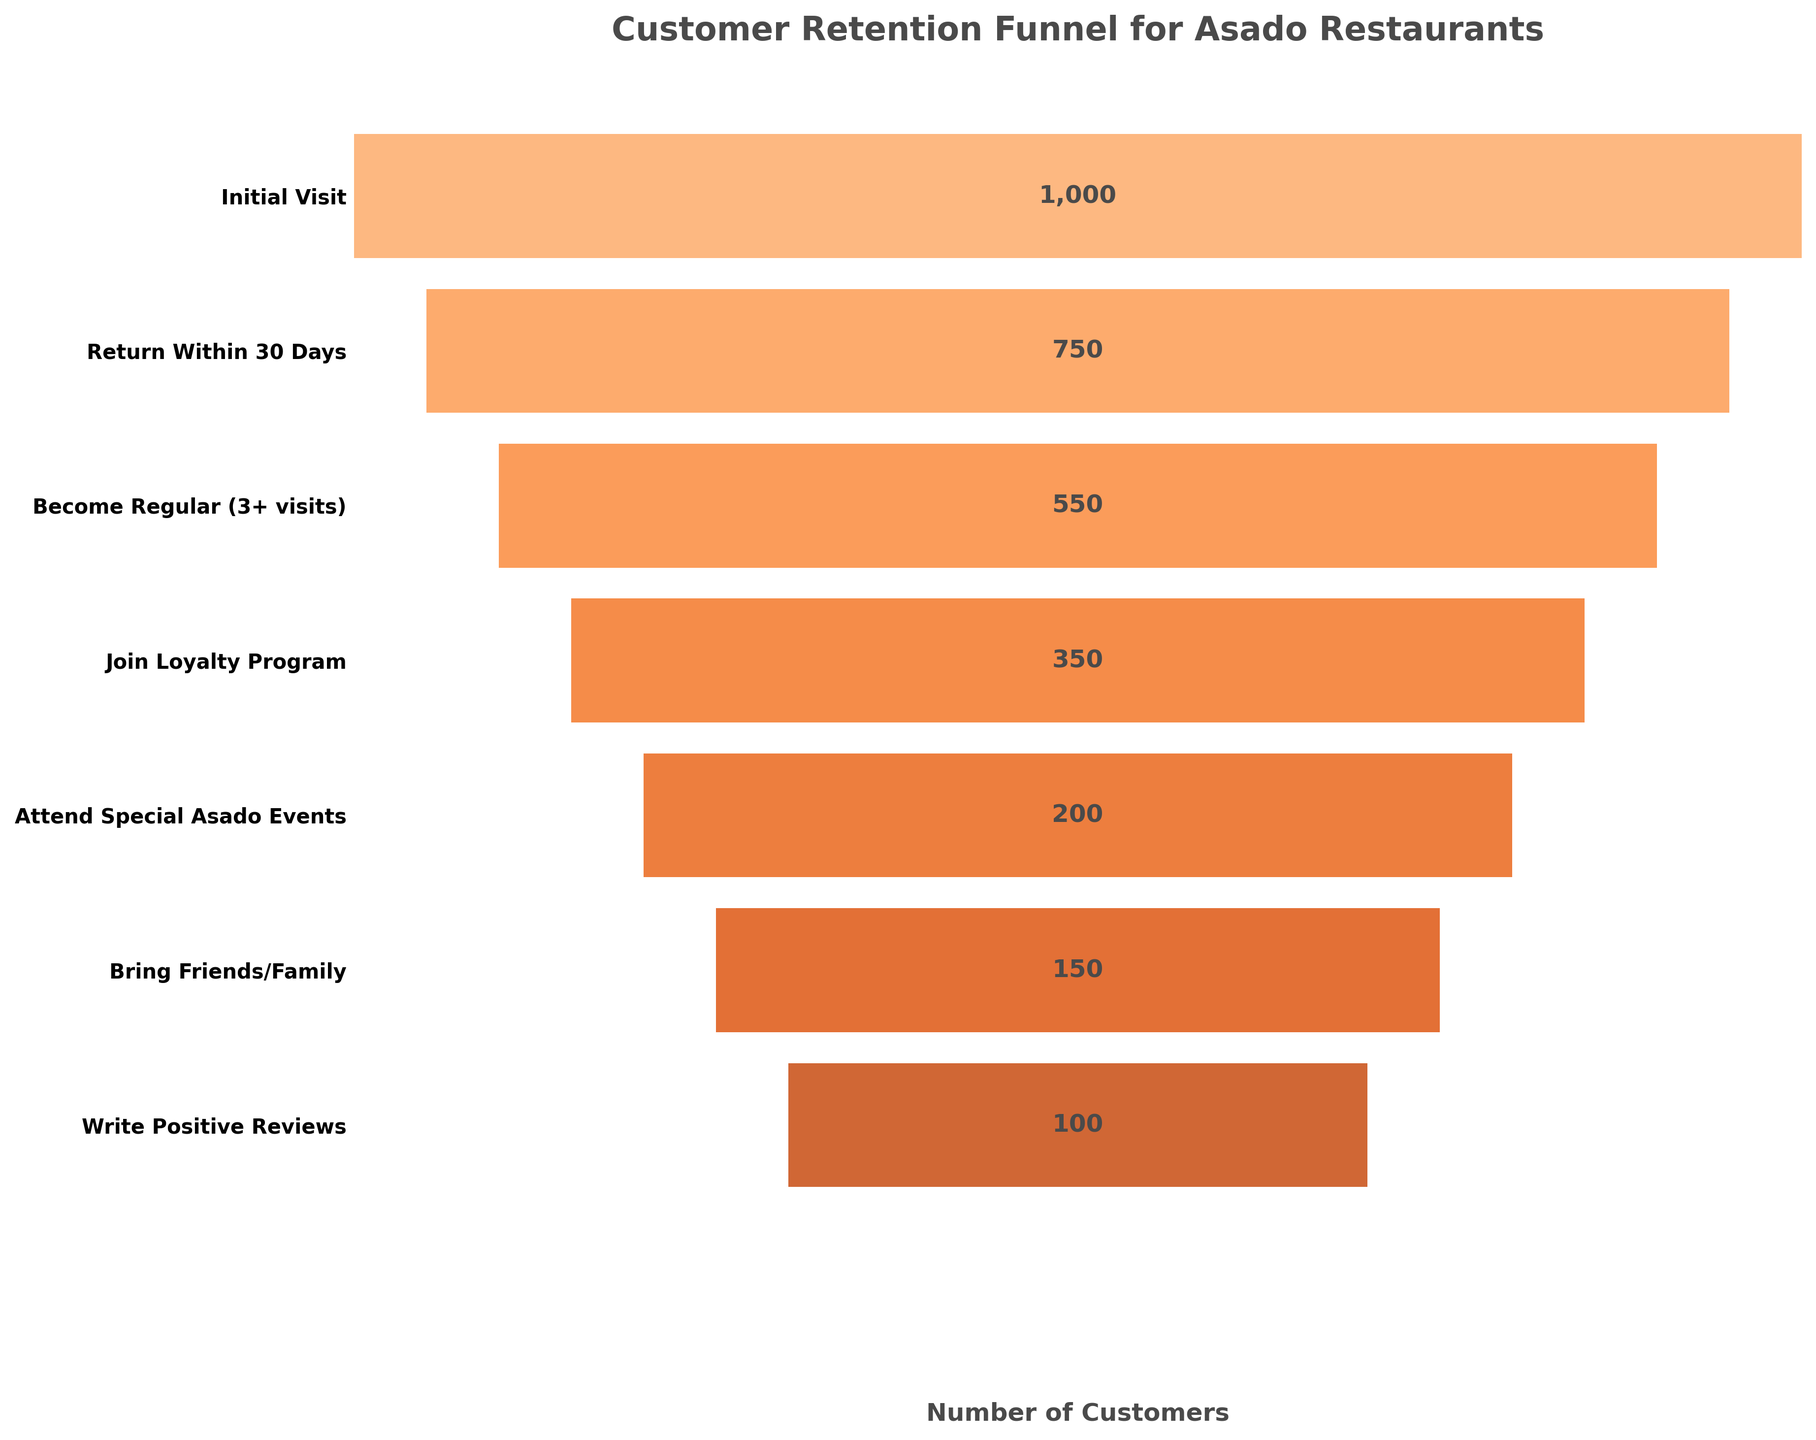What's the title of the graph? The title of the graph is displayed at the top and reads 'Customer Retention Funnel for Asado Restaurants'.
Answer: Customer Retention Funnel for Asado Restaurants How many stages are shown in the funnel? Count the number of stages listed on the y-axis. There are seven stages shown.
Answer: Seven How many customers return within 30 days? Look at the bar labeled 'Return Within 30 Days' and note the number at its center, which is 750.
Answer: 750 Which stage represents the first significant drop in customer retention? Compare the reductions in the number of customers between consecutive stages. The first significant drop is between 'Initial Visit' (1000) and 'Return Within 30 Days' (750), a drop of 250.
Answer: Return Within 30 Days What percentage of the initial visitors become regulars? Calculate the number of regular customers (550) as a percentage of the initial visitors (1000). The percentage is (550 / 1000) * 100 = 55%.
Answer: 55% How many more customers join the loyalty program compared to those who attend special asado events? Subtract the number of customers who attend special events (200) from those who join the loyalty program (350). The difference is 350 - 200 = 150.
Answer: 150 Which stage has the fewest number of customers? Identify the bar with the smallest number. The stage 'Write Positive Reviews' has the fewest customers at 100.
Answer: Write Positive Reviews What is the cumulative number of customers who either bring friends/family or write positive reviews? Add the number of customers for 'Bring Friends/Family' (150) and 'Write Positive Reviews' (100). The total is 150 + 100 = 250.
Answer: 250 Compare the number of customers who become regulars and those who bring friends/family. Which is greater and by how much? Subtract the number of customers who bring friends/family (150) from those who become regulars (550). The difference is 550 - 150 = 400, thus 'Become Regular' is greater by 400.
Answer: Become Regular by 400 What happens to customer numbers between the 'Join Loyalty Program' stage and the 'Attend Special Asado Events' stage? There is a decrease in customer numbers from 350 to 200, which means a decrease of 150 customers.
Answer: Decrease by 150 